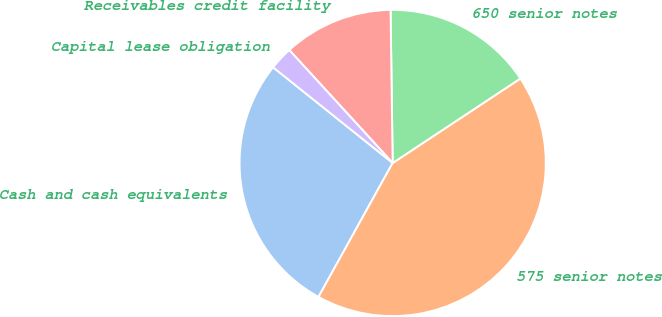<chart> <loc_0><loc_0><loc_500><loc_500><pie_chart><fcel>Cash and cash equivalents<fcel>575 senior notes<fcel>650 senior notes<fcel>Receivables credit facility<fcel>Capital lease obligation<nl><fcel>27.69%<fcel>42.35%<fcel>15.92%<fcel>11.58%<fcel>2.46%<nl></chart> 